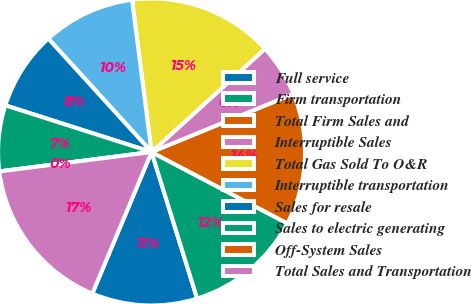Convert chart to OTSL. <chart><loc_0><loc_0><loc_500><loc_500><pie_chart><fcel>Full service<fcel>Firm transportation<fcel>Total Firm Sales and<fcel>Interruptible Sales<fcel>Total Gas Sold To O&R<fcel>Interruptible transportation<fcel>Sales for resale<fcel>Sales to electric generating<fcel>Off-System Sales<fcel>Total Sales and Transportation<nl><fcel>11.11%<fcel>12.5%<fcel>13.89%<fcel>5.56%<fcel>15.28%<fcel>9.72%<fcel>8.33%<fcel>6.94%<fcel>0.0%<fcel>16.67%<nl></chart> 